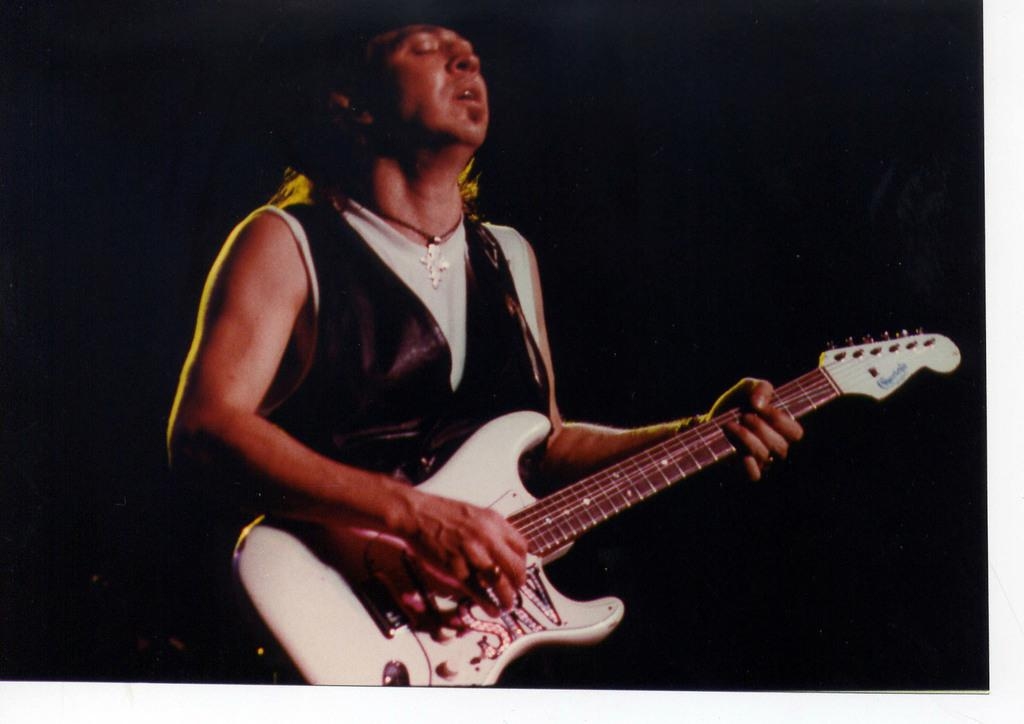Who is the main subject in the image? There is a man in the image. Where is the man positioned in the image? The man is standing at the center of the image. What is the man holding in the image? The man is holding a guitar. What is the color of the background in the image? The background of the image is black in color. What type of apparel is the man wearing that allows him to swing a blade in the image? There is no apparel, swinging, or blade present in the image. The man is simply holding a guitar. 